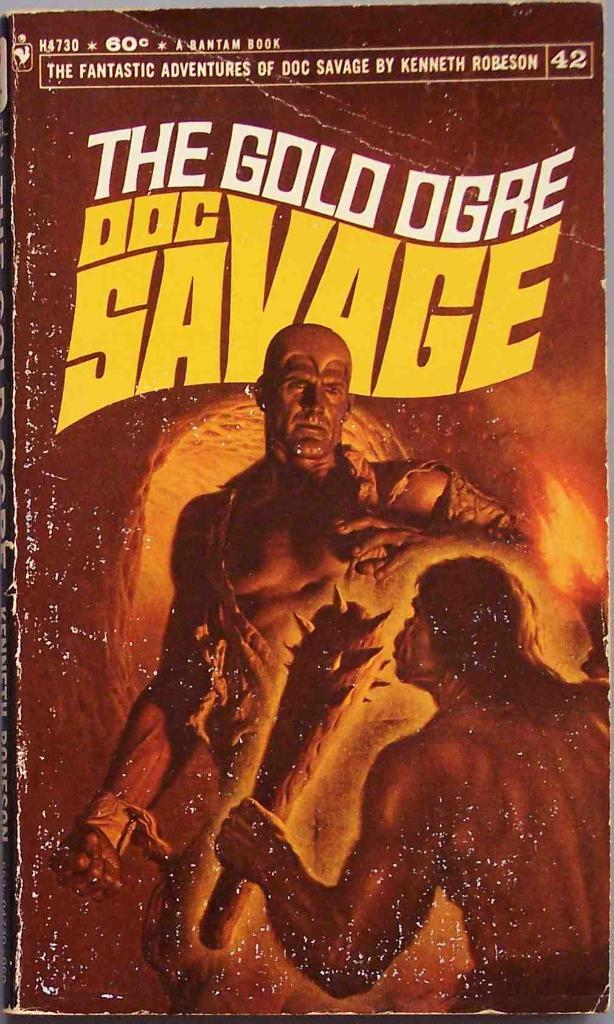Provide a one-sentence caption for the provided image. A paper back book titled The Gold Ogre Doc Savage. 